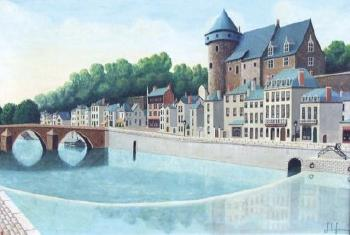Explain the visual content of the image in great detail. The image depicts a picturesque European town situated beside a serene, light blue river. The town is a delightful collection of buildings, each uniquely designed in various architectural styles. A prominent castle-like structure stands on the right, with its turret providing an impression of historical grandeur. The buildings are painted in warm colors such as white, beige, and red, creating an inviting atmosphere. Two arched stone bridges span the river, elegantly connecting different parts of the town. The trees in the background add a touch of natural greenery, contributing to the overall charm of the scene. The art style is realistic, effectively capturing the intricate details and character of the town and its serene surroundings. This painting can be classified as a landscape or cityscape, showcasing both the built environment and the natural beauty of the area. 